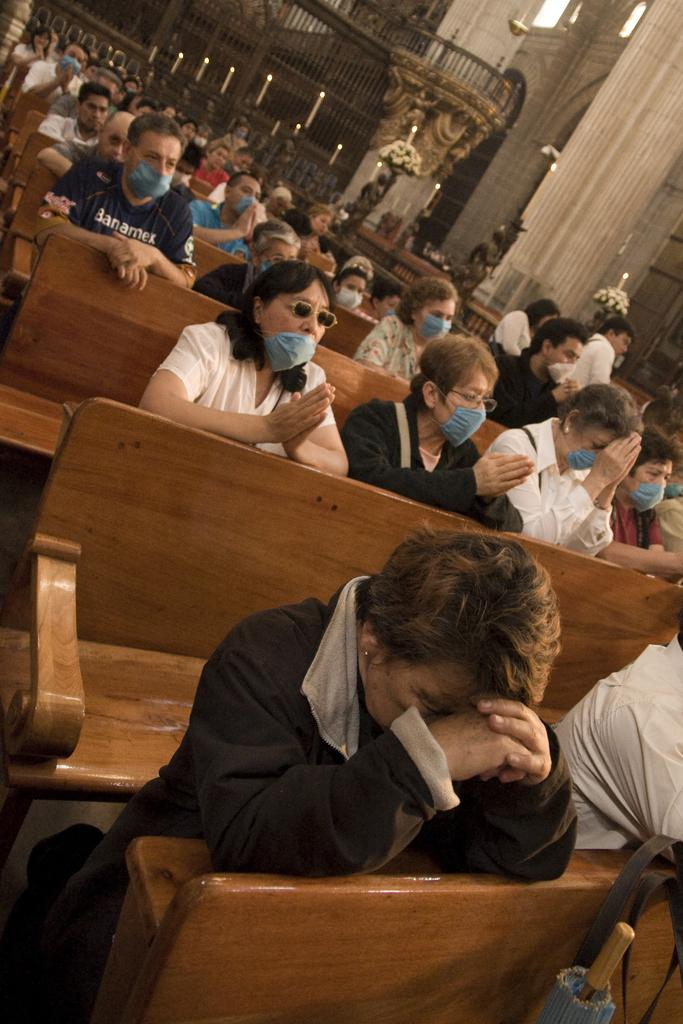What are the people in the image sitting on? The people in the image are sitting on wooden benches. What can be seen in the background of the image? There are many candles and pillars in the background of the image. What type of setting does the image resemble? The setting resembles a church. How many goldfish are swimming in the wooden benches in the image? There are no goldfish present in the image, as it features people sitting on wooden benches in a setting that resembles a church. 